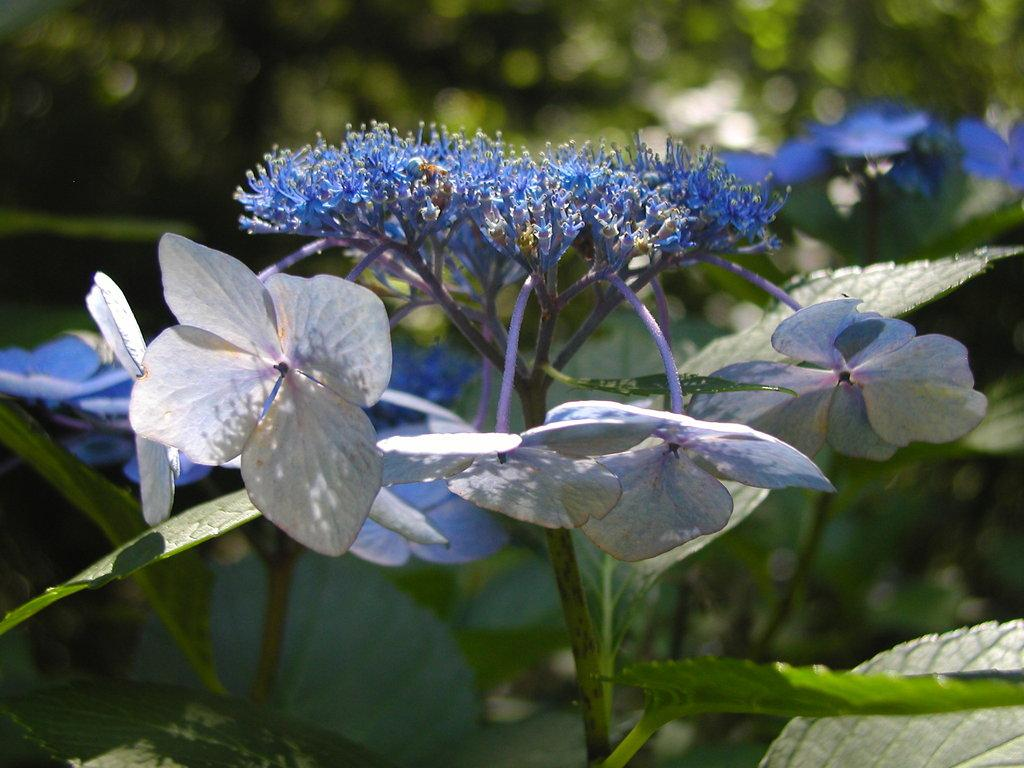What type of plants are present in the image? There are plants with flowers in the image. What color are the flowers on the plants? The flowers are blue in color. What can be seen in the background of the image? There are trees visible in the background of the image. Can you tell me which actor is picking the blue berries in the image? There are no berries, let alone blue berries, present in the image. The image features plants with blue flowers, not berries. 